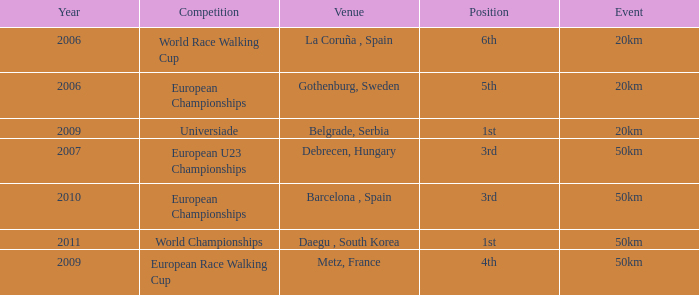What is the Position for the European U23 Championships? 3rd. 